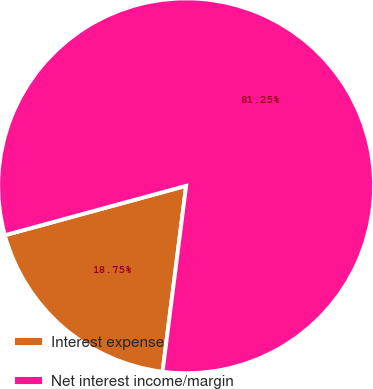<chart> <loc_0><loc_0><loc_500><loc_500><pie_chart><fcel>Interest expense<fcel>Net interest income/margin<nl><fcel>18.75%<fcel>81.25%<nl></chart> 